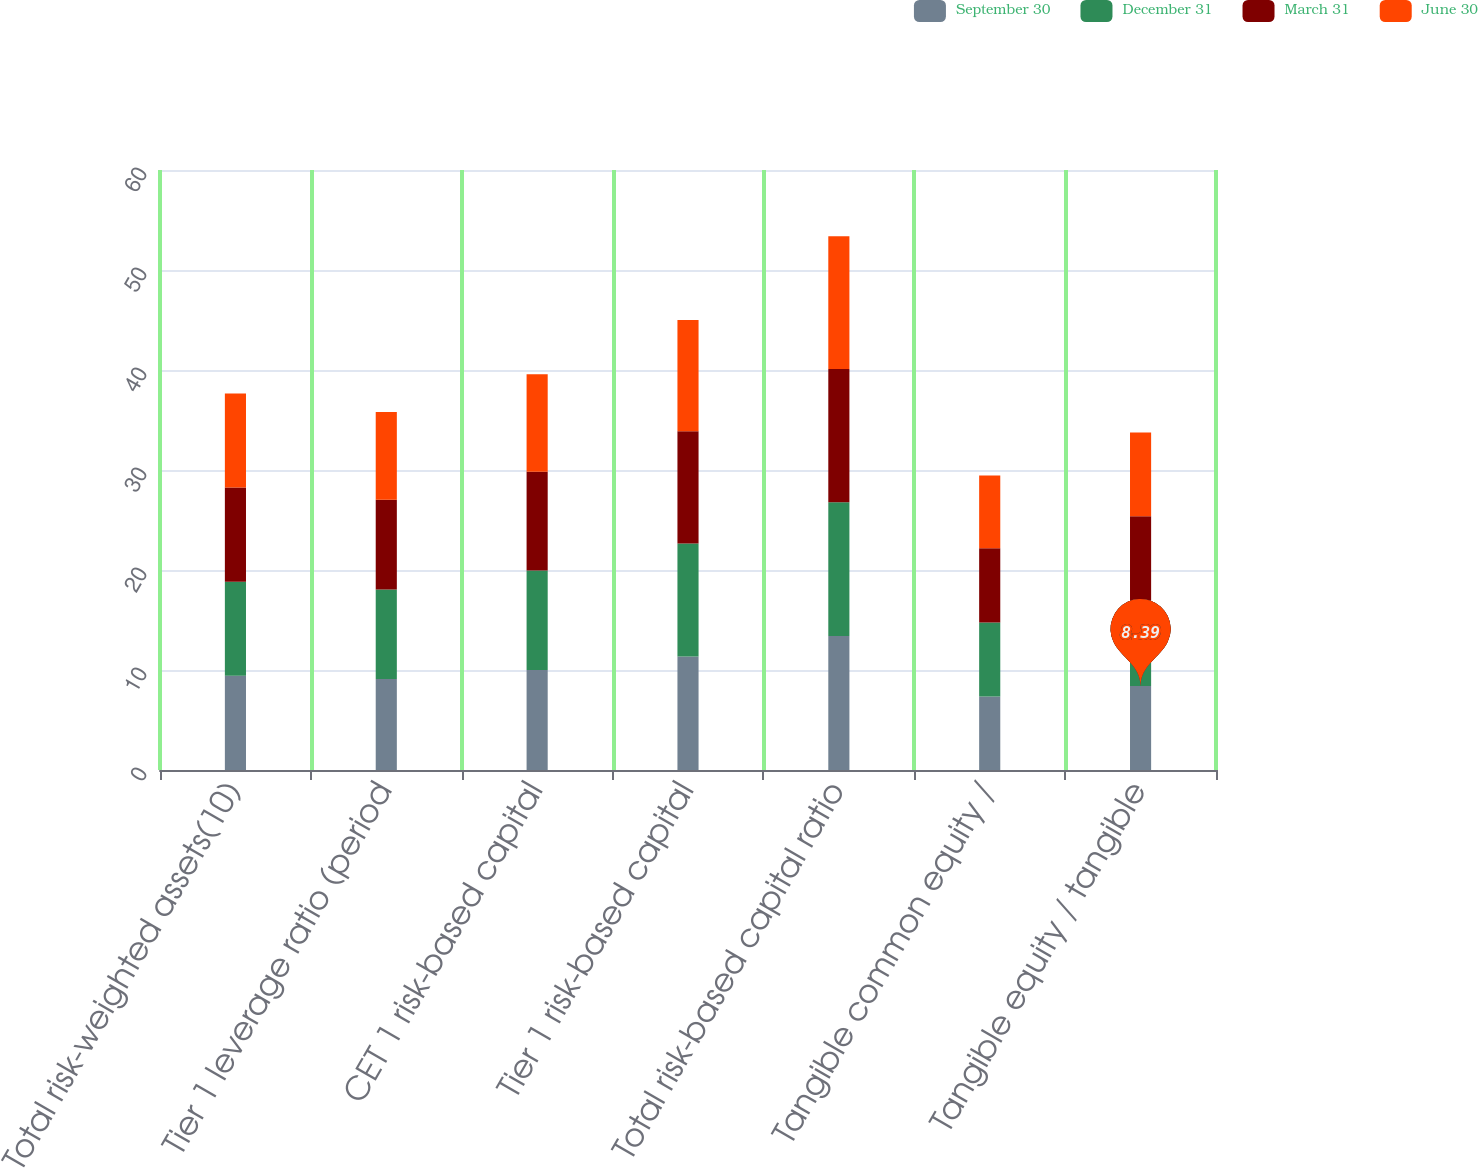Convert chart to OTSL. <chart><loc_0><loc_0><loc_500><loc_500><stacked_bar_chart><ecel><fcel>Total risk-weighted assets(10)<fcel>Tier 1 leverage ratio (period<fcel>CET 1 risk-based capital<fcel>Tier 1 risk-based capital<fcel>Total risk-based capital ratio<fcel>Tangible common equity /<fcel>Tangible equity / tangible<nl><fcel>September 30<fcel>9.415<fcel>9.09<fcel>10.01<fcel>11.34<fcel>13.39<fcel>7.34<fcel>8.39<nl><fcel>December 31<fcel>9.415<fcel>8.96<fcel>9.94<fcel>11.3<fcel>13.39<fcel>7.42<fcel>8.49<nl><fcel>March 31<fcel>9.415<fcel>8.98<fcel>9.88<fcel>11.24<fcel>13.33<fcel>7.41<fcel>8.49<nl><fcel>June 30<fcel>9.415<fcel>8.76<fcel>9.74<fcel>11.11<fcel>13.26<fcel>7.28<fcel>8.38<nl></chart> 